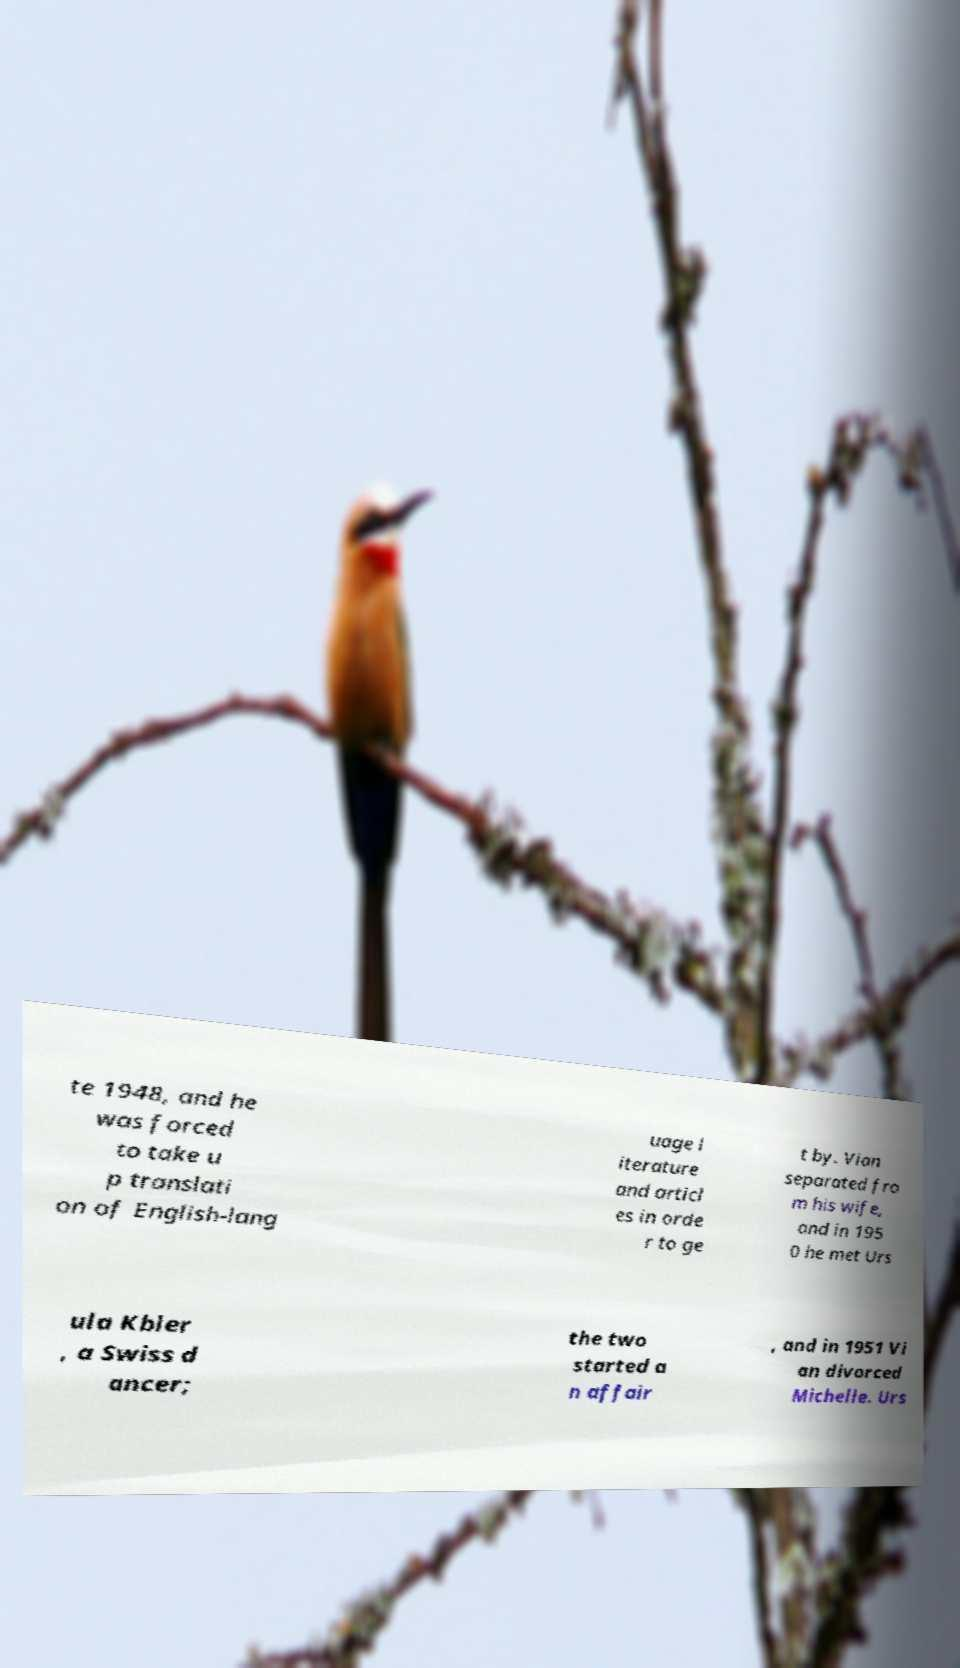Can you read and provide the text displayed in the image?This photo seems to have some interesting text. Can you extract and type it out for me? te 1948, and he was forced to take u p translati on of English-lang uage l iterature and articl es in orde r to ge t by. Vian separated fro m his wife, and in 195 0 he met Urs ula Kbler , a Swiss d ancer; the two started a n affair , and in 1951 Vi an divorced Michelle. Urs 